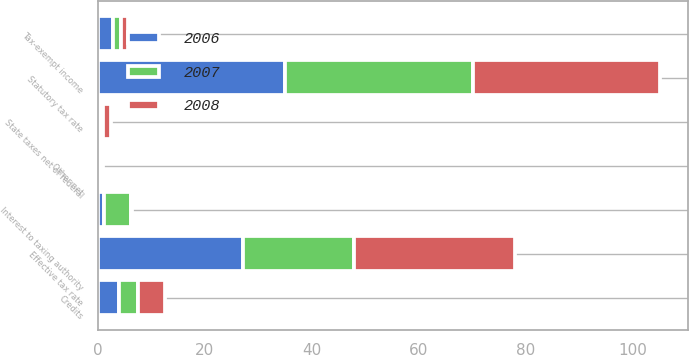<chart> <loc_0><loc_0><loc_500><loc_500><stacked_bar_chart><ecel><fcel>Statutory tax rate<fcel>State taxes net of federal<fcel>Tax-exempt income<fcel>Credits<fcel>Interest to taxing authority<fcel>Other net<fcel>Effective tax rate<nl><fcel>2007<fcel>35<fcel>0.5<fcel>1.5<fcel>3.6<fcel>5.1<fcel>0.1<fcel>20.7<nl><fcel>2008<fcel>35<fcel>1.5<fcel>1.4<fcel>5<fcel>0.1<fcel>0.5<fcel>30<nl><fcel>2006<fcel>35<fcel>0.4<fcel>2.8<fcel>3.9<fcel>1.1<fcel>0.4<fcel>27.2<nl></chart> 